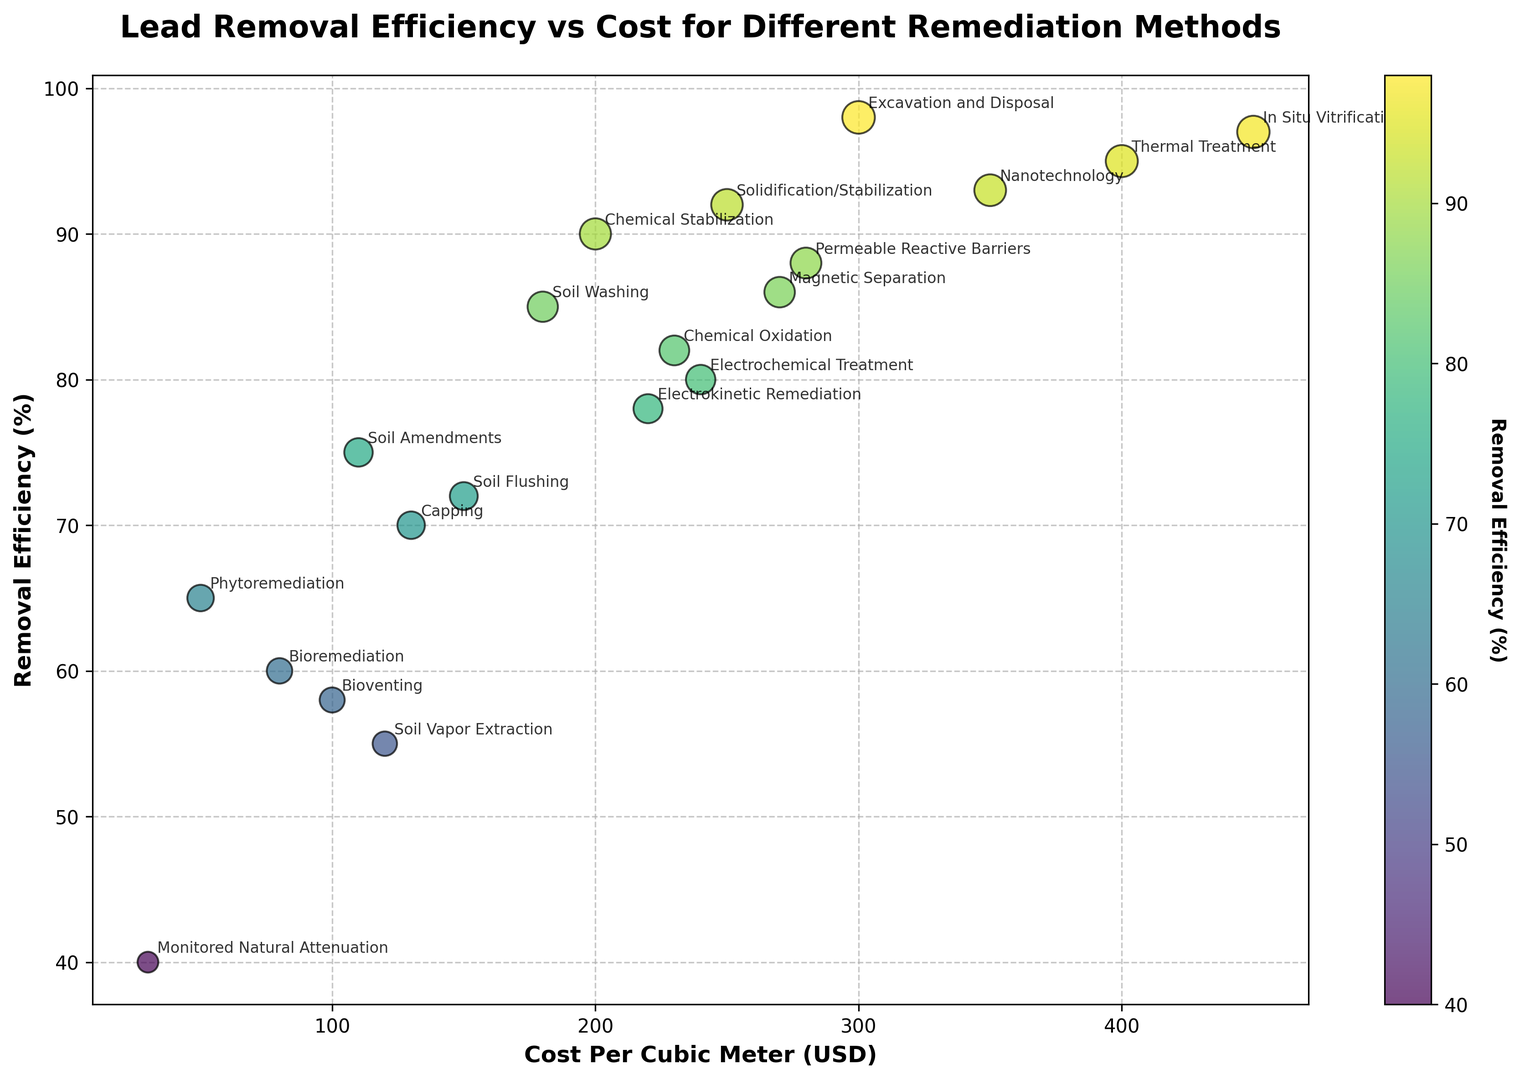Which remediation method has the highest lead removal efficiency? Look at the y-axis (Removal Efficiency %) to find the method with the maximum value. The highest value is 98%, corresponding to Excavation and Disposal.
Answer: Excavation and Disposal What is the cost per cubic meter for the method with the lowest removal efficiency? Identify the lowest point on the y-axis (Removal Efficiency %), which is 40%. This value corresponds to Monitored Natural Attenuation on the x-axis (Cost Per Cubic Meter USD).
Answer: 30 USD Compare the lead removal efficiency and cost between Phytoremediation and Bioremediation. Look at the points representing Phytoremediation and Bioremediation on the graph. Phytoremediation has a removal efficiency of 65% and a cost of 50 USD, while Bioremediation has a removal efficiency of 60% and a cost of 80 USD.
Answer: Phytoremediation: 65% and 50 USD, Bioremediation: 60% and 80 USD Which method provides a removal efficiency greater than 90% but costs less than 300 USD per cubic meter? Look for points on the graph where the y-axis value is greater than 90% and the x-axis value is less than 300 USD. The method that fits this criteria is Solidification/Stabilization with a 92% removal efficiency and 250 USD cost.
Answer: Solidification/Stabilization What is the average removal efficiency of methods costing more than 200 USD per cubic meter? First, identify the methods costing more than 200 USD: Electrokinetic Remediation, Chemical Stabilization, Thermal Treatment, Permeable Reactive Barriers, Nanotechnology, Chemical Oxidation, Magnetic Separation, Electrochemical Treatment, and In Situ Vitrification. Then calculate their average removal efficiencies: (78% + 90% + 95% + 88% + 93% + 82% + 86% + 80% + 97%) / 9 = 855 / 9 = 95%.
Answer: 95% Is there a remediation method with removal efficiency around 70% and what is its cost? Look around the 70% mark on the y-axis. Soil Flushing has a removal efficiency of 72% and a cost of 150 USD. Capping has a removal efficiency of 70% and a cost of 130 USD. Both are close to 70%.
Answer: Soil Flushing: 150 USD, Capping: 130 USD Which method has the largest size marker representing lead removal efficiency? Determine the method with the largest circular marker on the scatter plot. The biggest marker corresponds to In Situ Vitrification with a removal efficiency of 97%.
Answer: In Situ Vitrification 